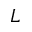Convert formula to latex. <formula><loc_0><loc_0><loc_500><loc_500>L</formula> 